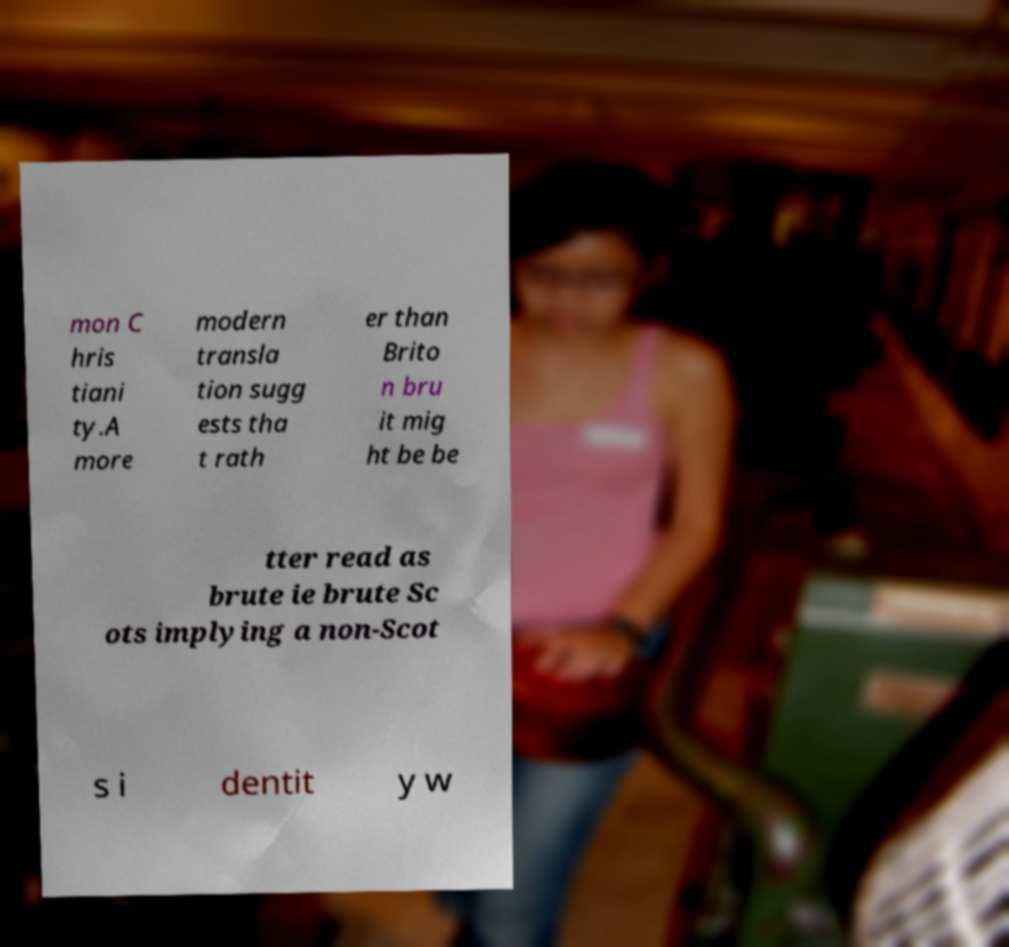There's text embedded in this image that I need extracted. Can you transcribe it verbatim? mon C hris tiani ty.A more modern transla tion sugg ests tha t rath er than Brito n bru it mig ht be be tter read as brute ie brute Sc ots implying a non-Scot s i dentit y w 